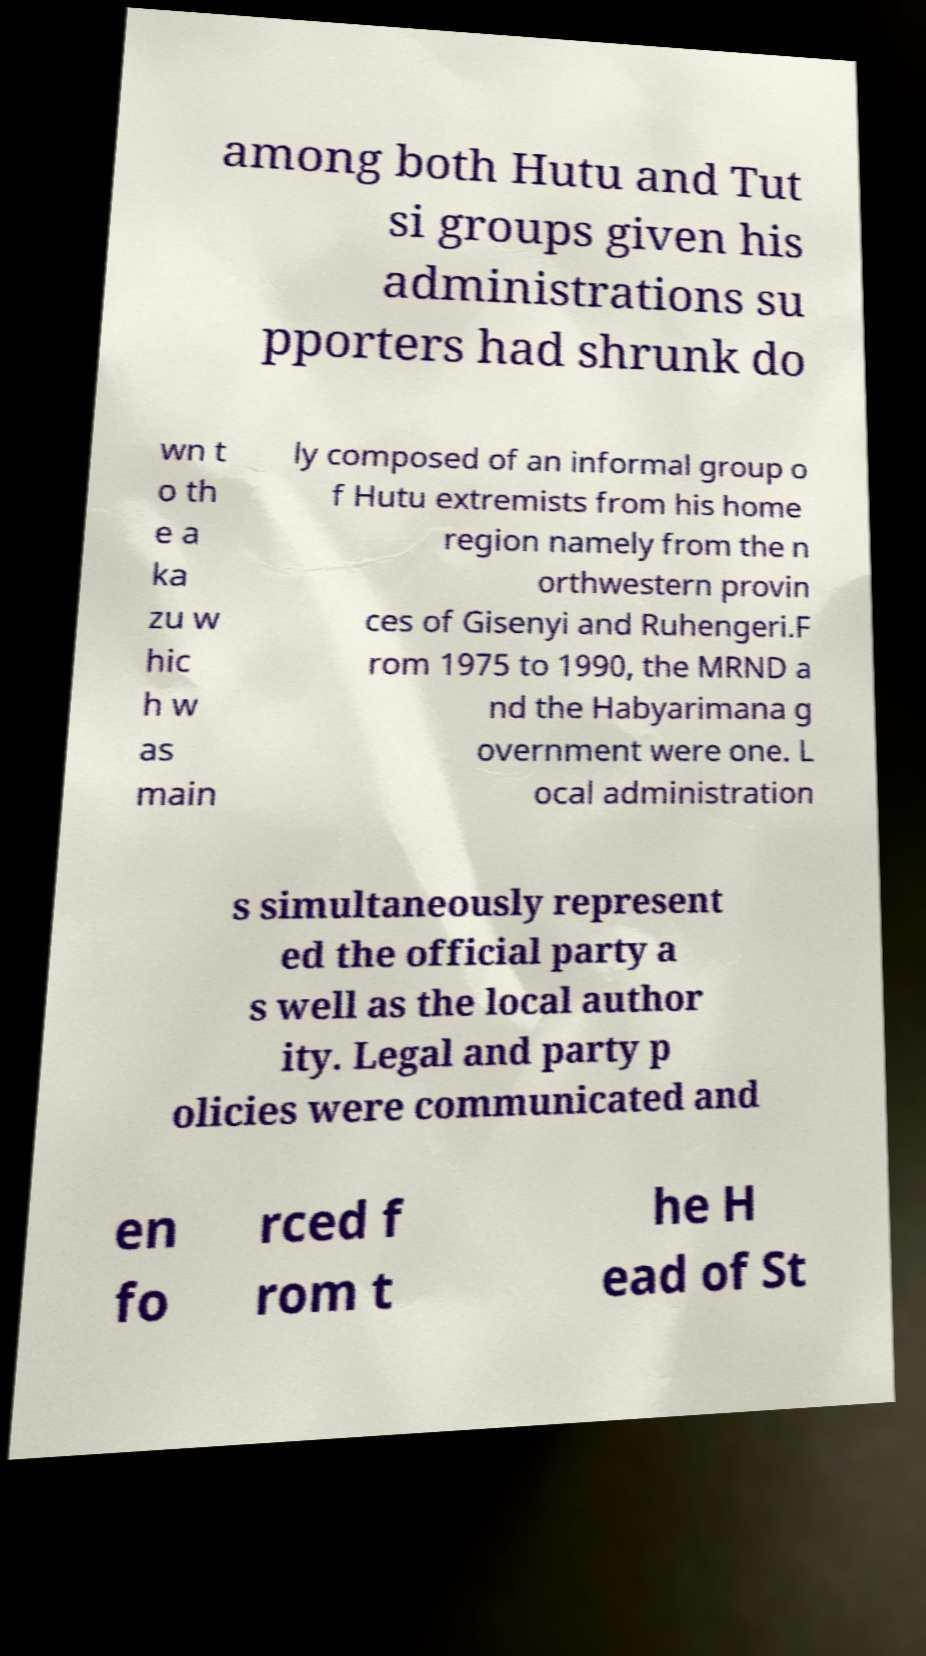Could you assist in decoding the text presented in this image and type it out clearly? among both Hutu and Tut si groups given his administrations su pporters had shrunk do wn t o th e a ka zu w hic h w as main ly composed of an informal group o f Hutu extremists from his home region namely from the n orthwestern provin ces of Gisenyi and Ruhengeri.F rom 1975 to 1990, the MRND a nd the Habyarimana g overnment were one. L ocal administration s simultaneously represent ed the official party a s well as the local author ity. Legal and party p olicies were communicated and en fo rced f rom t he H ead of St 